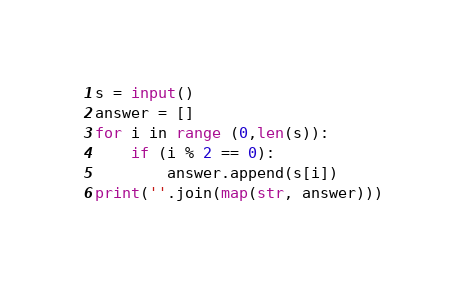<code> <loc_0><loc_0><loc_500><loc_500><_Python_>s = input()
answer = []
for i in range (0,len(s)):
    if (i % 2 == 0):
        answer.append(s[i])
print(''.join(map(str, answer)))</code> 